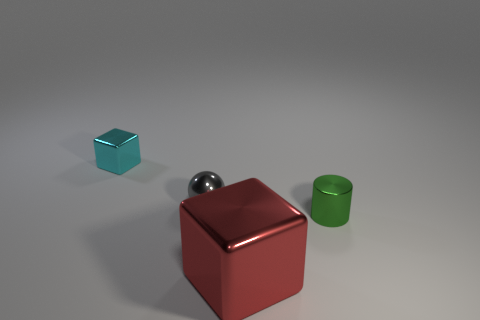Does the large red object have the same shape as the thing on the right side of the big object?
Offer a very short reply. No. How big is the red metal block?
Provide a succinct answer. Large. Is the number of metallic blocks behind the red metal block less than the number of big red metallic things?
Your answer should be compact. No. How many gray blocks have the same size as the cyan shiny thing?
Your answer should be very brief. 0. What number of blocks are in front of the tiny sphere?
Offer a very short reply. 1. Is there another metallic object of the same shape as the tiny green thing?
Keep it short and to the point. No. The cylinder that is the same size as the gray metallic thing is what color?
Ensure brevity in your answer.  Green. Are there fewer large metallic objects that are behind the tiny cyan cube than red objects that are in front of the green metallic thing?
Keep it short and to the point. Yes. There is a shiny block that is on the left side of the gray metal sphere; is it the same size as the gray metallic object?
Keep it short and to the point. Yes. The object that is behind the sphere has what shape?
Your response must be concise. Cube. 